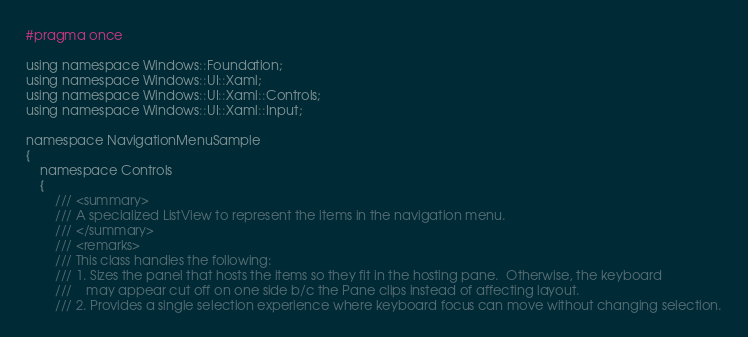Convert code to text. <code><loc_0><loc_0><loc_500><loc_500><_C_>#pragma once

using namespace Windows::Foundation;
using namespace Windows::UI::Xaml;
using namespace Windows::UI::Xaml::Controls;
using namespace Windows::UI::Xaml::Input;

namespace NavigationMenuSample
{
    namespace Controls
    {
        /// <summary>
        /// A specialized ListView to represent the items in the navigation menu.
        /// </summary>
        /// <remarks>
        /// This class handles the following:
        /// 1. Sizes the panel that hosts the items so they fit in the hosting pane.  Otherwise, the keyboard 
        ///    may appear cut off on one side b/c the Pane clips instead of affecting layout.
        /// 2. Provides a single selection experience where keyboard focus can move without changing selection.</code> 